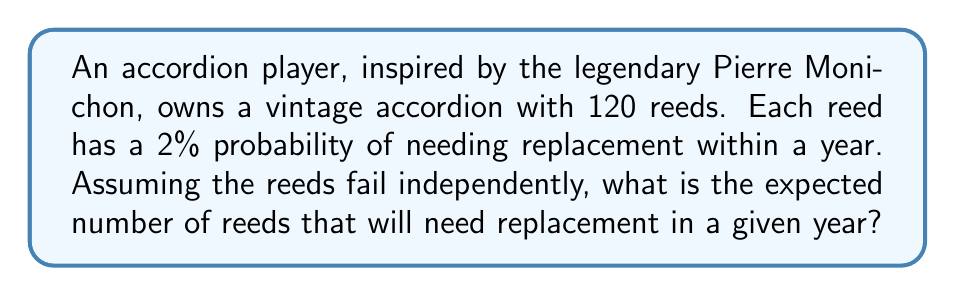Solve this math problem. To solve this problem, we need to understand the concept of expected value for a binomial distribution.

1) Each reed can be considered a Bernoulli trial, where:
   - Success (needs replacement) probability = $p = 0.02$
   - Failure (doesn't need replacement) probability = $1 - p = 0.98$

2) With 120 reeds, we have a binomial distribution $B(n,p)$ where:
   - $n = 120$ (number of trials)
   - $p = 0.02$ (probability of success)

3) The expected value of a binomial distribution is given by:

   $$E(X) = np$$

   Where:
   - $E(X)$ is the expected value
   - $n$ is the number of trials
   - $p$ is the probability of success

4) Substituting our values:

   $$E(X) = 120 \times 0.02 = 2.4$$

Therefore, the expected number of reeds needing replacement in a given year is 2.4.
Answer: 2.4 reeds 